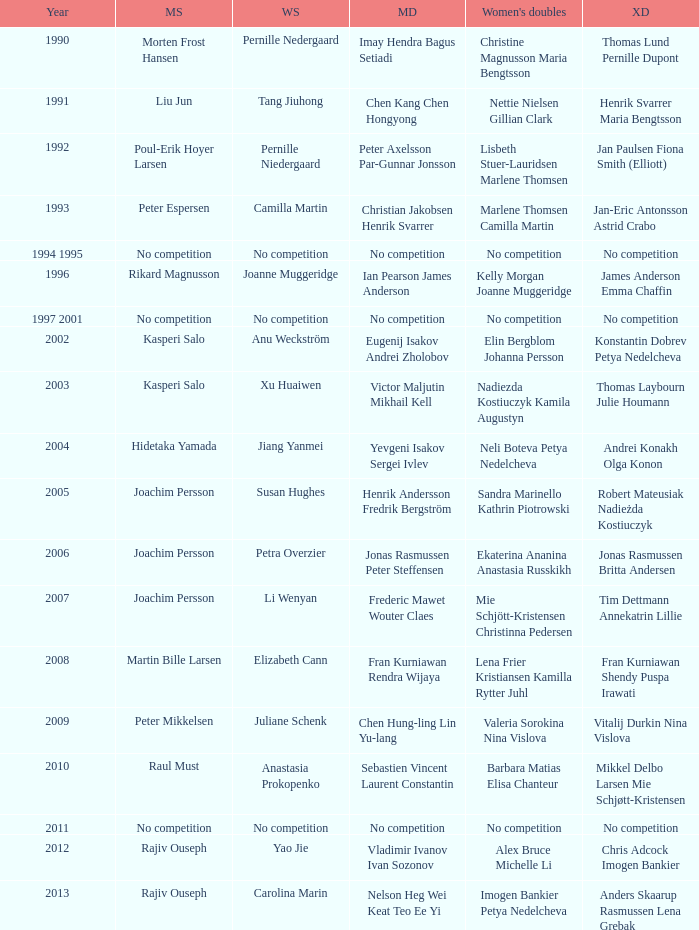What year did Carolina Marin win the Women's singles? 2013.0. 